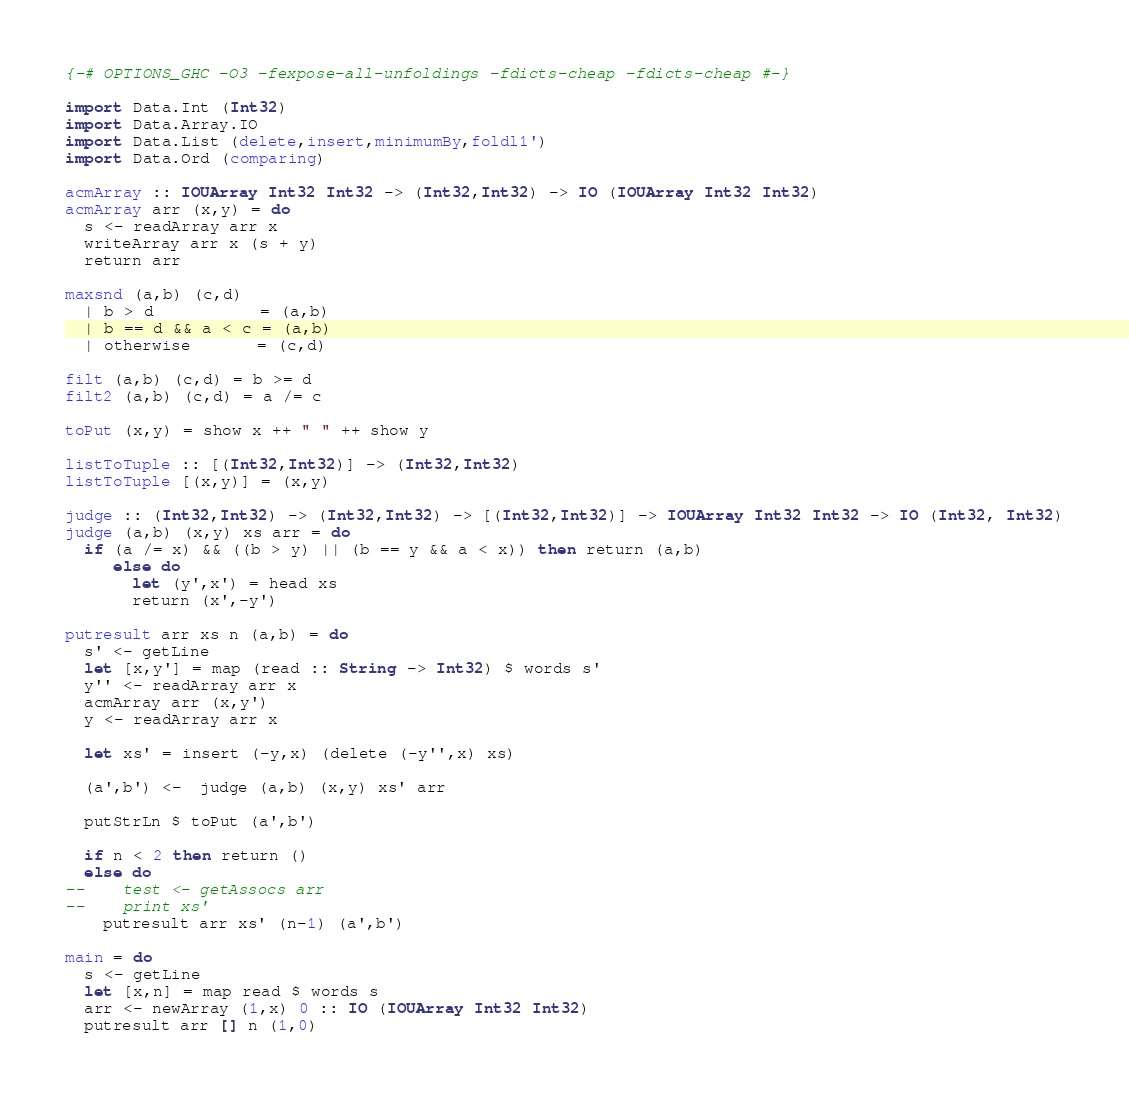<code> <loc_0><loc_0><loc_500><loc_500><_Haskell_>{-# OPTIONS_GHC -O3 -fexpose-all-unfoldings -fdicts-cheap -fdicts-cheap #-}
 
import Data.Int (Int32)
import Data.Array.IO
import Data.List (delete,insert,minimumBy,foldl1')
import Data.Ord (comparing)
 
acmArray :: IOUArray Int32 Int32 -> (Int32,Int32) -> IO (IOUArray Int32 Int32)
acmArray arr (x,y) = do
  s <- readArray arr x
  writeArray arr x (s + y)
  return arr
 
maxsnd (a,b) (c,d)
  | b > d           = (a,b)
  | b == d && a < c = (a,b)
  | otherwise       = (c,d)
 
filt (a,b) (c,d) = b >= d
filt2 (a,b) (c,d) = a /= c
 
toPut (x,y) = show x ++ " " ++ show y
 
listToTuple :: [(Int32,Int32)] -> (Int32,Int32)
listToTuple [(x,y)] = (x,y)
 
judge :: (Int32,Int32) -> (Int32,Int32) -> [(Int32,Int32)] -> IOUArray Int32 Int32 -> IO (Int32, Int32)
judge (a,b) (x,y) xs arr = do
  if (a /= x) && ((b > y) || (b == y && a < x)) then return (a,b)
     else do
       let (y',x') = head xs
       return (x',-y')
 
putresult arr xs n (a,b) = do
  s' <- getLine
  let [x,y'] = map (read :: String -> Int32) $ words s'
  y'' <- readArray arr x
  acmArray arr (x,y')
  y <- readArray arr x
 
  let xs' = insert (-y,x) (delete (-y'',x) xs)
 
  (a',b') <-  judge (a,b) (x,y) xs' arr
 
  putStrLn $ toPut (a',b')
 
  if n < 2 then return ()
  else do
--    test <- getAssocs arr
--    print xs'
    putresult arr xs' (n-1) (a',b')
 
main = do
  s <- getLine
  let [x,n] = map read $ words s
  arr <- newArray (1,x) 0 :: IO (IOUArray Int32 Int32)
  putresult arr [] n (1,0)</code> 